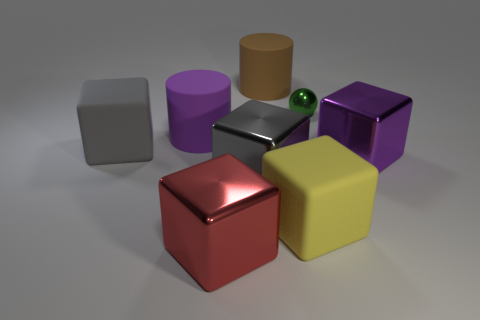Subtract all large yellow cubes. How many cubes are left? 4 Add 1 tiny green metal things. How many objects exist? 9 Subtract all purple cubes. How many cubes are left? 4 Subtract 1 cubes. How many cubes are left? 4 Subtract 0 gray balls. How many objects are left? 8 Subtract all cubes. How many objects are left? 3 Subtract all cyan balls. Subtract all brown cubes. How many balls are left? 1 Subtract all yellow cubes. How many brown cylinders are left? 1 Subtract all yellow objects. Subtract all big yellow rubber things. How many objects are left? 6 Add 2 gray matte cubes. How many gray matte cubes are left? 3 